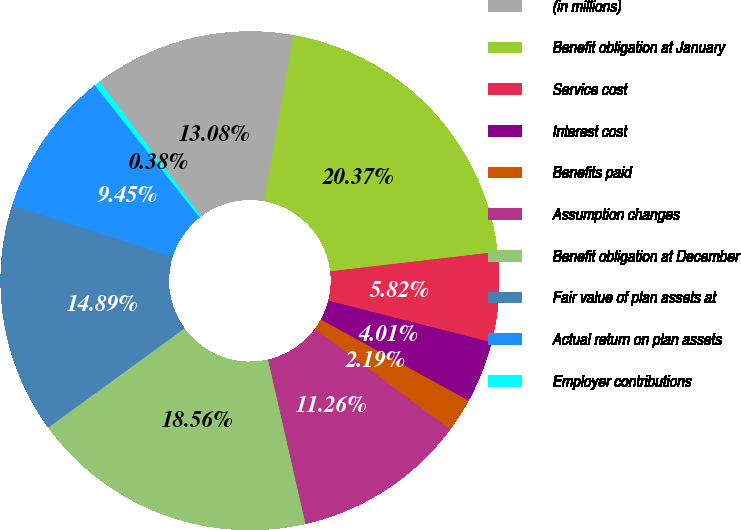Convert chart to OTSL. <chart><loc_0><loc_0><loc_500><loc_500><pie_chart><fcel>(in millions)<fcel>Benefit obligation at January<fcel>Service cost<fcel>Interest cost<fcel>Benefits paid<fcel>Assumption changes<fcel>Benefit obligation at December<fcel>Fair value of plan assets at<fcel>Actual return on plan assets<fcel>Employer contributions<nl><fcel>13.08%<fcel>20.37%<fcel>5.82%<fcel>4.01%<fcel>2.19%<fcel>11.26%<fcel>18.56%<fcel>14.89%<fcel>9.45%<fcel>0.38%<nl></chart> 